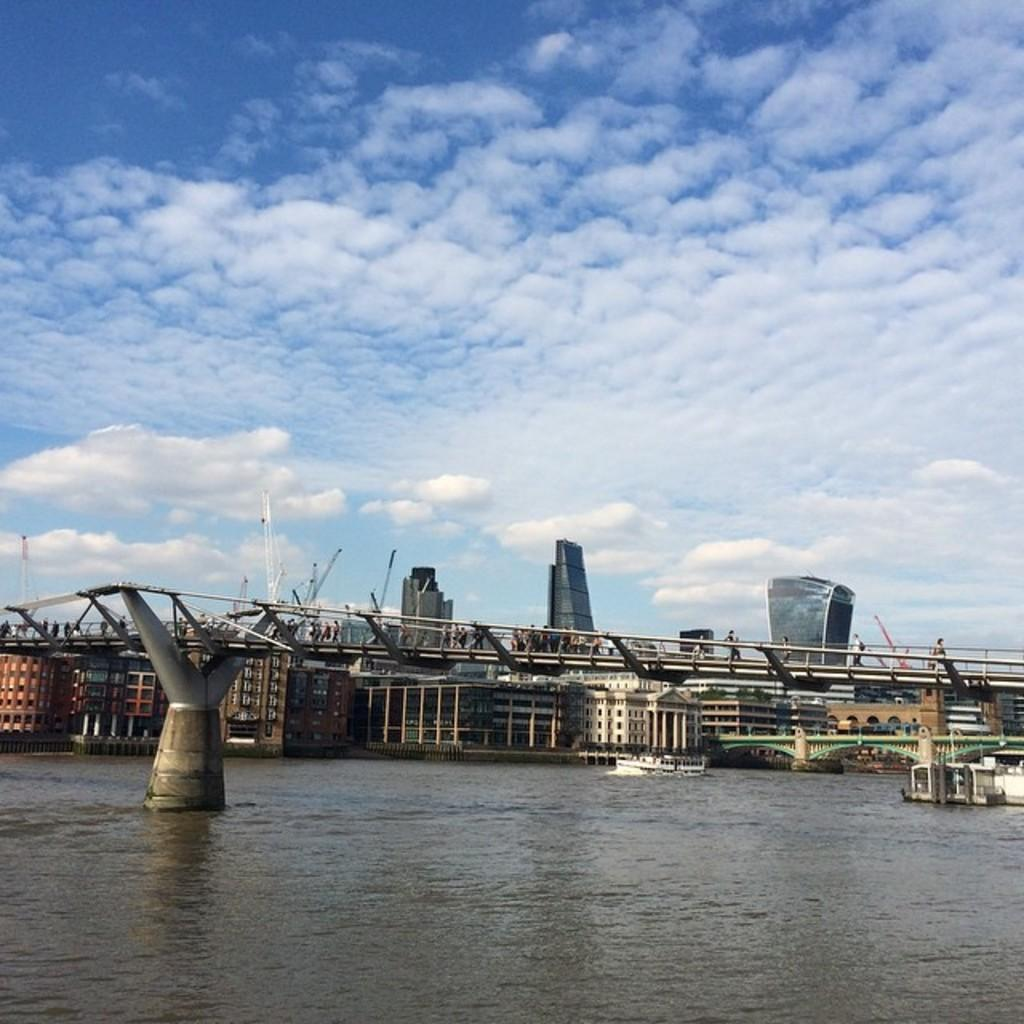What is the main subject of the image? The main subject of the image is a boat on the water. What else can be seen in the image besides the boat? There is a bridge and buildings in the background of the image. What is visible in the sky at the top of the image? Clouds are visible in the sky at the top of the image. How does the police comb the existence of the boat in the image? There is no police or comb present in the image, and the existence of the boat is clearly visible. 